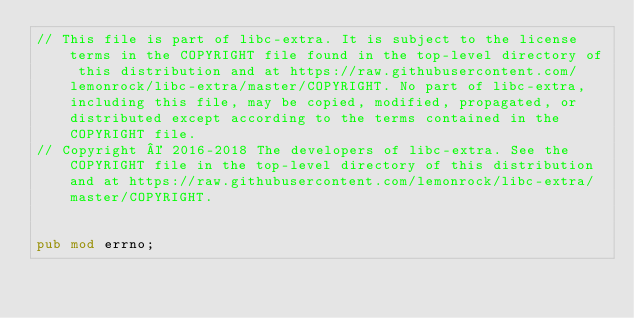Convert code to text. <code><loc_0><loc_0><loc_500><loc_500><_Rust_>// This file is part of libc-extra. It is subject to the license terms in the COPYRIGHT file found in the top-level directory of this distribution and at https://raw.githubusercontent.com/lemonrock/libc-extra/master/COPYRIGHT. No part of libc-extra, including this file, may be copied, modified, propagated, or distributed except according to the terms contained in the COPYRIGHT file.
// Copyright © 2016-2018 The developers of libc-extra. See the COPYRIGHT file in the top-level directory of this distribution and at https://raw.githubusercontent.com/lemonrock/libc-extra/master/COPYRIGHT.


pub mod errno;</code> 